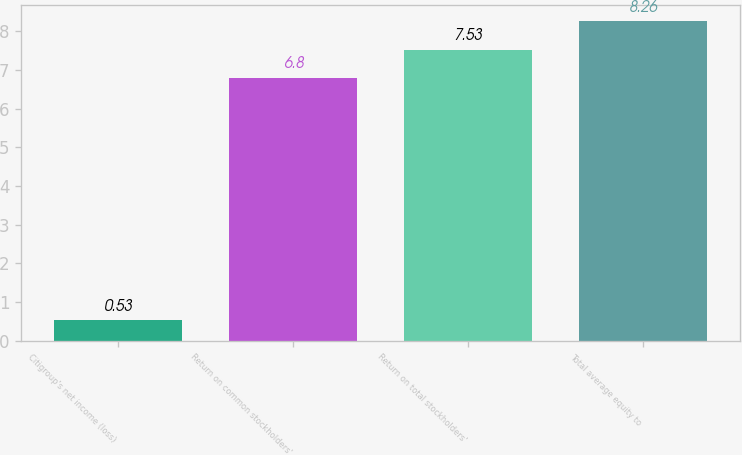<chart> <loc_0><loc_0><loc_500><loc_500><bar_chart><fcel>Citigroup's net income (loss)<fcel>Return on common stockholders'<fcel>Return on total stockholders'<fcel>Total average equity to<nl><fcel>0.53<fcel>6.8<fcel>7.53<fcel>8.26<nl></chart> 